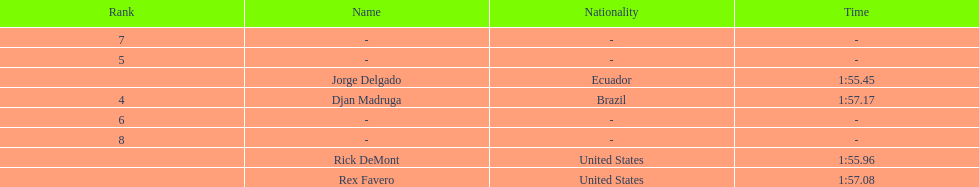Who finished with the top time? Jorge Delgado. 